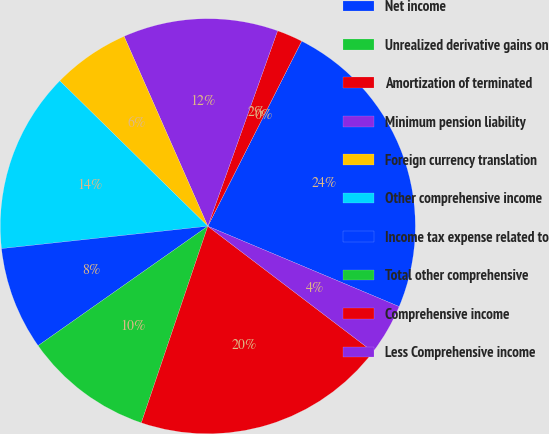Convert chart to OTSL. <chart><loc_0><loc_0><loc_500><loc_500><pie_chart><fcel>Net income<fcel>Unrealized derivative gains on<fcel>Amortization of terminated<fcel>Minimum pension liability<fcel>Foreign currency translation<fcel>Other comprehensive income<fcel>Income tax expense related to<fcel>Total other comprehensive<fcel>Comprehensive income<fcel>Less Comprehensive income<nl><fcel>23.86%<fcel>0.0%<fcel>2.01%<fcel>12.07%<fcel>6.03%<fcel>14.08%<fcel>8.04%<fcel>10.05%<fcel>19.84%<fcel>4.02%<nl></chart> 